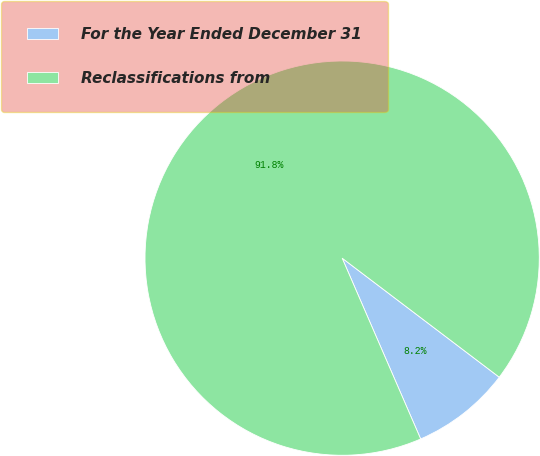Convert chart. <chart><loc_0><loc_0><loc_500><loc_500><pie_chart><fcel>For the Year Ended December 31<fcel>Reclassifications from<nl><fcel>8.16%<fcel>91.84%<nl></chart> 